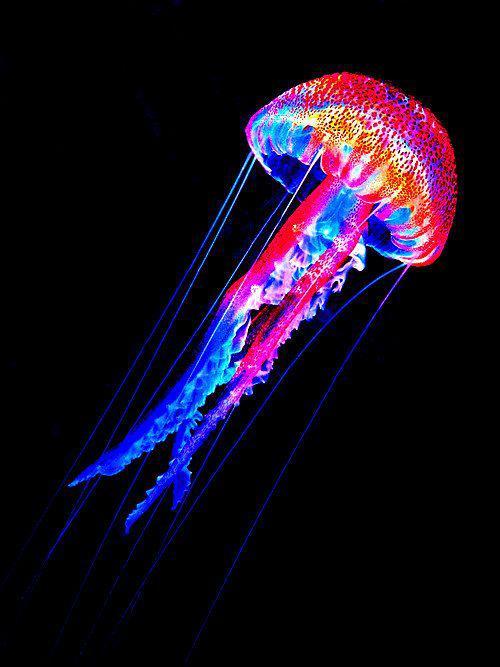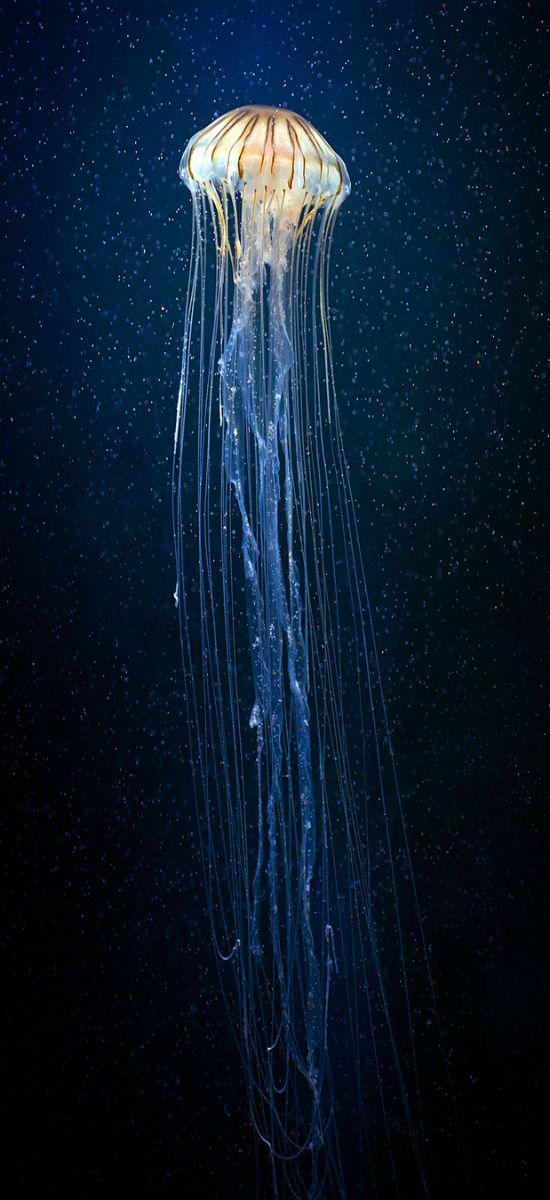The first image is the image on the left, the second image is the image on the right. Assess this claim about the two images: "Each image shows a translucent bluish-white jellyfish shaped like a mushroom, with threadlike and ruffly tentacles trailing under it.". Correct or not? Answer yes or no. No. The first image is the image on the left, the second image is the image on the right. For the images shown, is this caption "In at least one image there is on blue lit jellyfish whose head cap is straight up and down." true? Answer yes or no. Yes. 